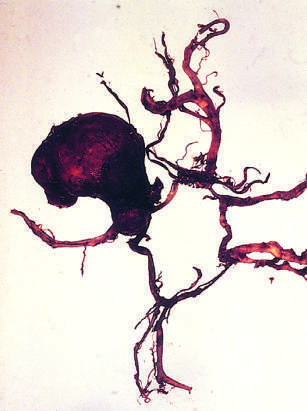s acute promyelocytic leukemia-bone marrow dissected to show a large aneurysm?
Answer the question using a single word or phrase. No 